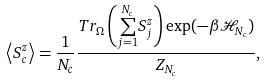<formula> <loc_0><loc_0><loc_500><loc_500>\left \langle S _ { c } ^ { z } \right \rangle = \frac { 1 } { N _ { c } } \frac { T r _ { \Omega } \left ( \overset { N _ { c } } { \underset { j = 1 } { \sum } } S _ { j } ^ { z } \right ) \exp ( - \beta \mathcal { H } _ { N _ { c } } ) } { Z _ { N _ { c } } } ,</formula> 